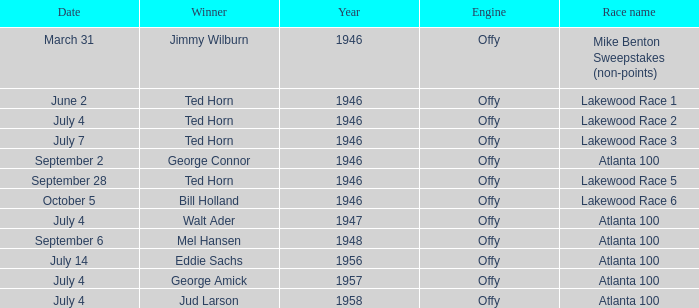Who won on September 6? Mel Hansen. 